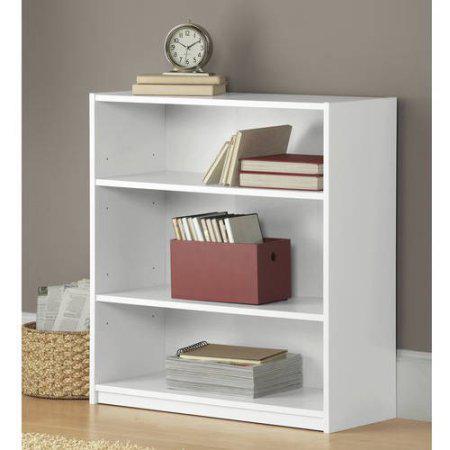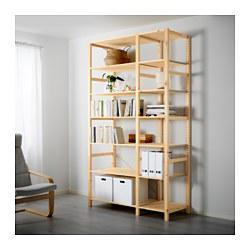The first image is the image on the left, the second image is the image on the right. For the images shown, is this caption "In one image, a shelf unit has six levels and an open back, while the shelf unit in the second image has fewer shelves and a solid enclosed back." true? Answer yes or no. Yes. The first image is the image on the left, the second image is the image on the right. Examine the images to the left and right. Is the description "An image shows a white storage unit with at least one item on its flat top." accurate? Answer yes or no. Yes. 